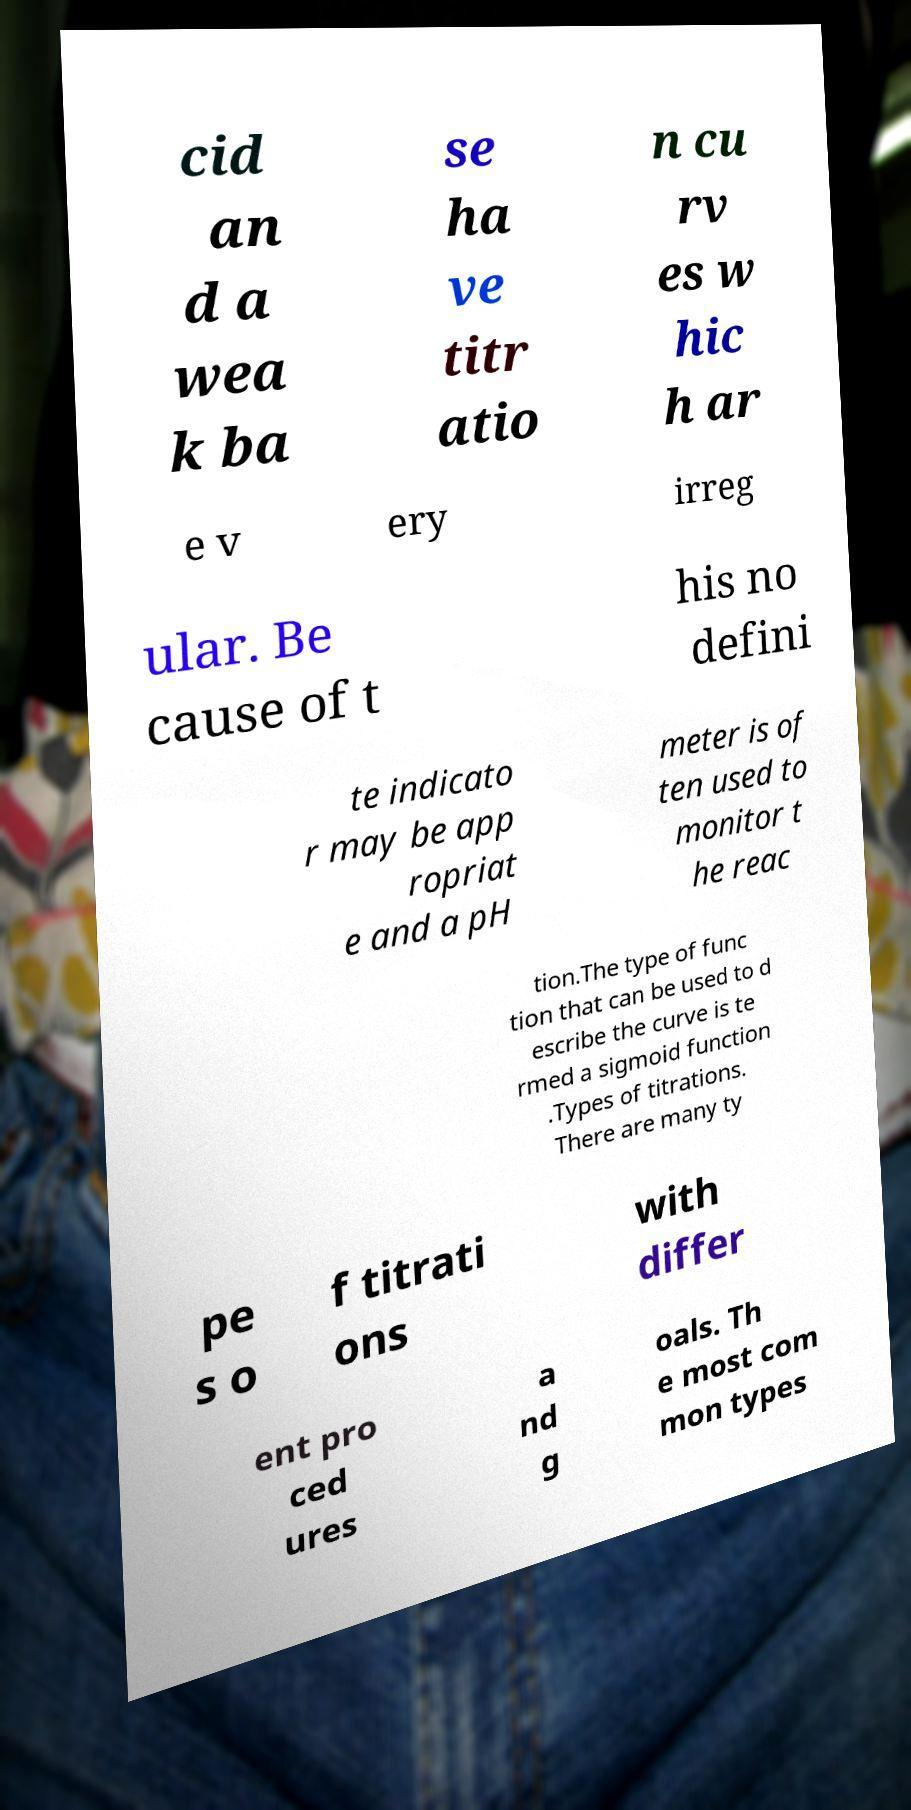There's text embedded in this image that I need extracted. Can you transcribe it verbatim? cid an d a wea k ba se ha ve titr atio n cu rv es w hic h ar e v ery irreg ular. Be cause of t his no defini te indicato r may be app ropriat e and a pH meter is of ten used to monitor t he reac tion.The type of func tion that can be used to d escribe the curve is te rmed a sigmoid function .Types of titrations. There are many ty pe s o f titrati ons with differ ent pro ced ures a nd g oals. Th e most com mon types 